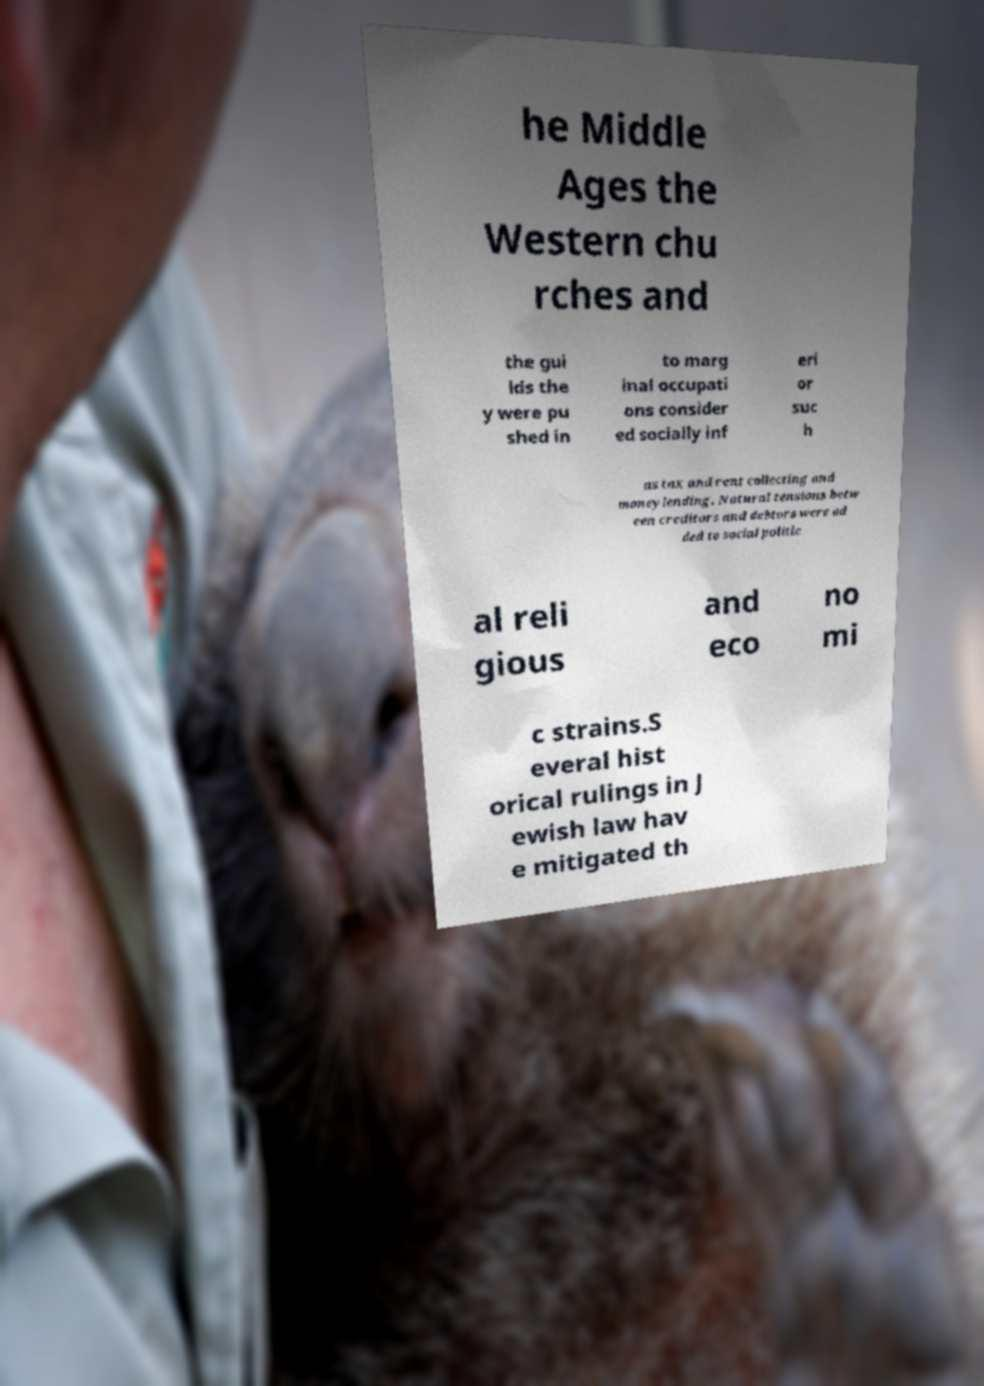Could you assist in decoding the text presented in this image and type it out clearly? he Middle Ages the Western chu rches and the gui lds the y were pu shed in to marg inal occupati ons consider ed socially inf eri or suc h as tax and rent collecting and moneylending. Natural tensions betw een creditors and debtors were ad ded to social politic al reli gious and eco no mi c strains.S everal hist orical rulings in J ewish law hav e mitigated th 